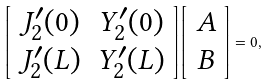<formula> <loc_0><loc_0><loc_500><loc_500>\left [ \begin{array} { c c } J _ { 2 } ^ { \prime } ( 0 ) & Y _ { 2 } ^ { \prime } ( 0 ) \\ J _ { 2 } ^ { \prime } ( L ) & Y _ { 2 } ^ { \prime } ( L ) \end{array} \right ] \left [ \begin{array} { c } A \\ B \end{array} \right ] = 0 ,</formula> 